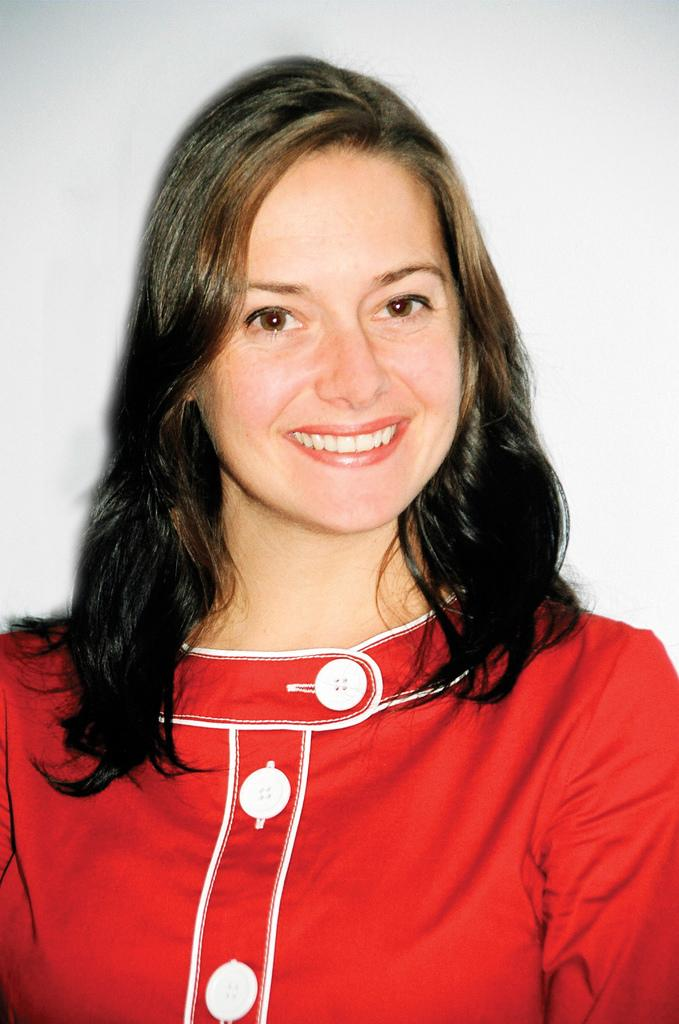Who is present in the image? There is a woman in the image. What is the woman wearing? The woman is wearing a red dress. What expression does the woman have? The woman is smiling. What can be seen in the background of the image? There is a wall in the background of the image. What time does the clock on the wall indicate in the image? There is no clock present in the image, so it is not possible to determine the time. 